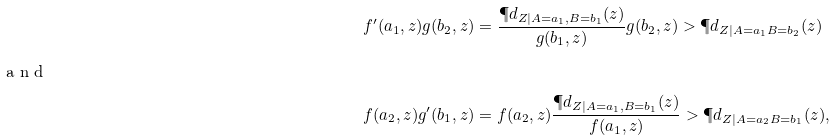<formula> <loc_0><loc_0><loc_500><loc_500>f ^ { \prime } ( a _ { 1 } , z ) g ( b _ { 2 } , z ) & = \frac { \P d _ { Z | A = a _ { 1 } , B = b _ { 1 } } ( z ) } { g ( b _ { 1 } , z ) } g ( b _ { 2 } , z ) > \P d _ { Z | A = a _ { 1 } B = b _ { 2 } } ( z ) \\ \intertext { a n d } f ( a _ { 2 } , z ) g ^ { \prime } ( b _ { 1 } , z ) & = f ( a _ { 2 } , z ) \frac { \P d _ { Z | A = a _ { 1 } , B = b _ { 1 } } ( z ) } { f ( a _ { 1 } , z ) } > \P d _ { Z | A = a _ { 2 } B = b _ { 1 } } ( z ) ,</formula> 